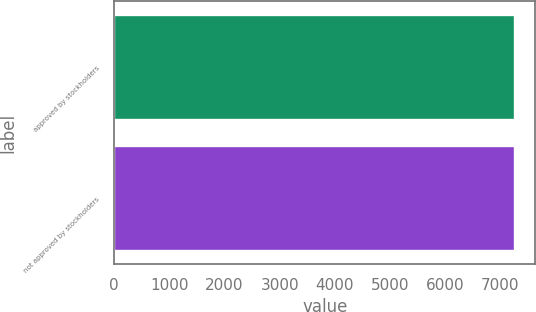<chart> <loc_0><loc_0><loc_500><loc_500><bar_chart><fcel>approved by stockholders<fcel>not approved by stockholders<nl><fcel>7269<fcel>7269.1<nl></chart> 